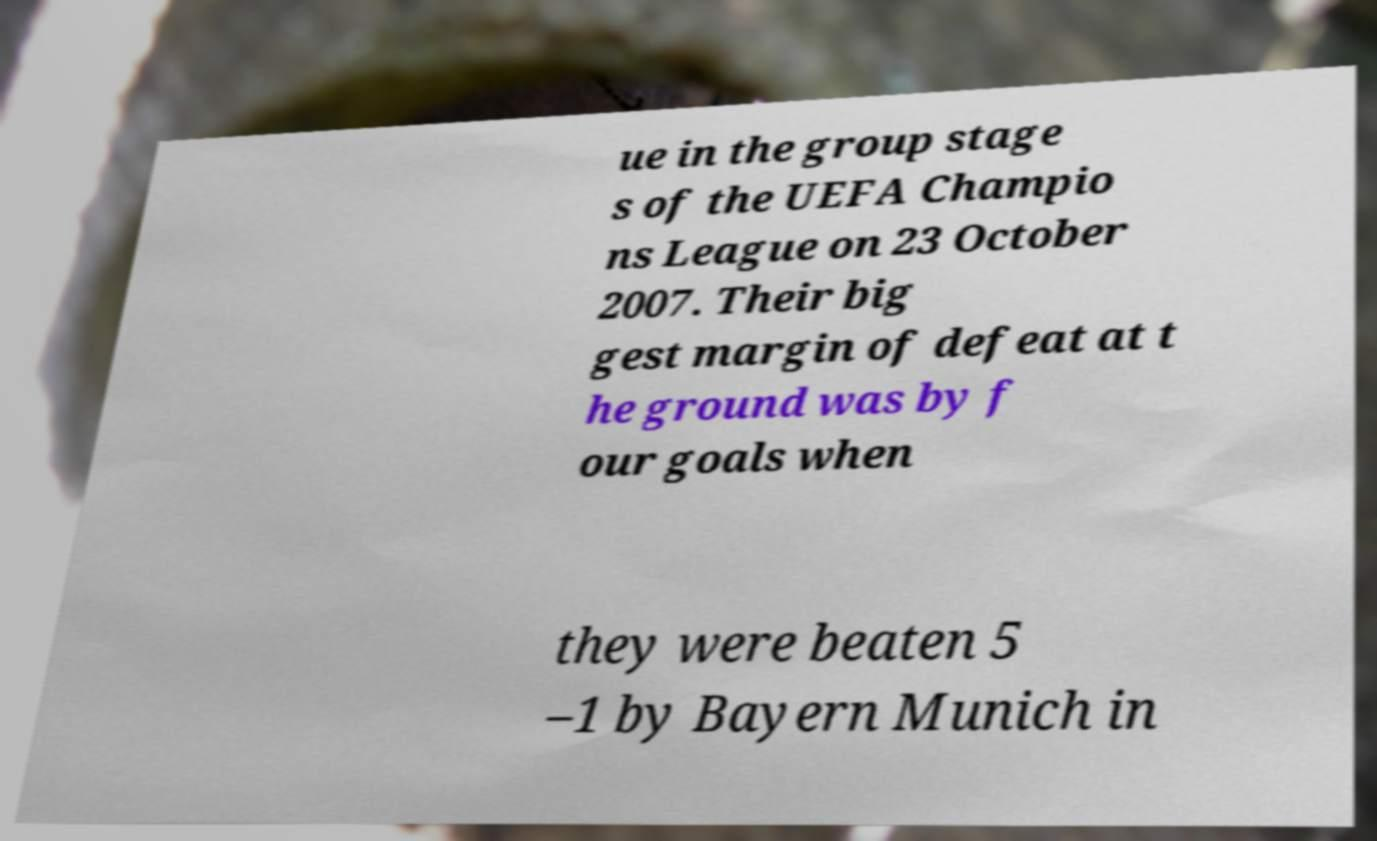For documentation purposes, I need the text within this image transcribed. Could you provide that? ue in the group stage s of the UEFA Champio ns League on 23 October 2007. Their big gest margin of defeat at t he ground was by f our goals when they were beaten 5 –1 by Bayern Munich in 